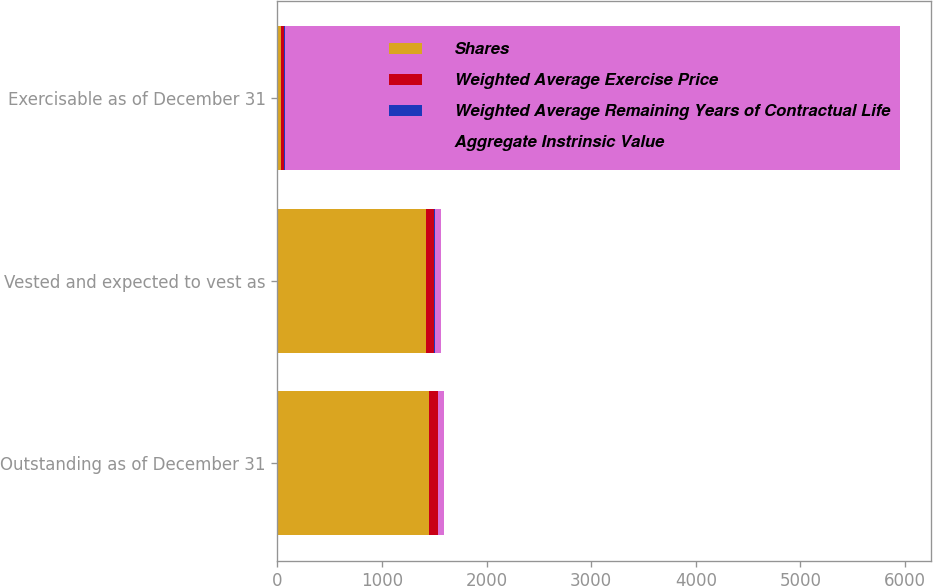<chart> <loc_0><loc_0><loc_500><loc_500><stacked_bar_chart><ecel><fcel>Outstanding as of December 31<fcel>Vested and expected to vest as<fcel>Exercisable as of December 31<nl><fcel>Shares<fcel>1451<fcel>1417<fcel>33<nl><fcel>Weighted Average Exercise Price<fcel>82.56<fcel>82.4<fcel>32.4<nl><fcel>Weighted Average Remaining Years of Contractual Life<fcel>5.8<fcel>5.8<fcel>2.3<nl><fcel>Aggregate Instrinsic Value<fcel>57.7<fcel>57.7<fcel>5883<nl></chart> 